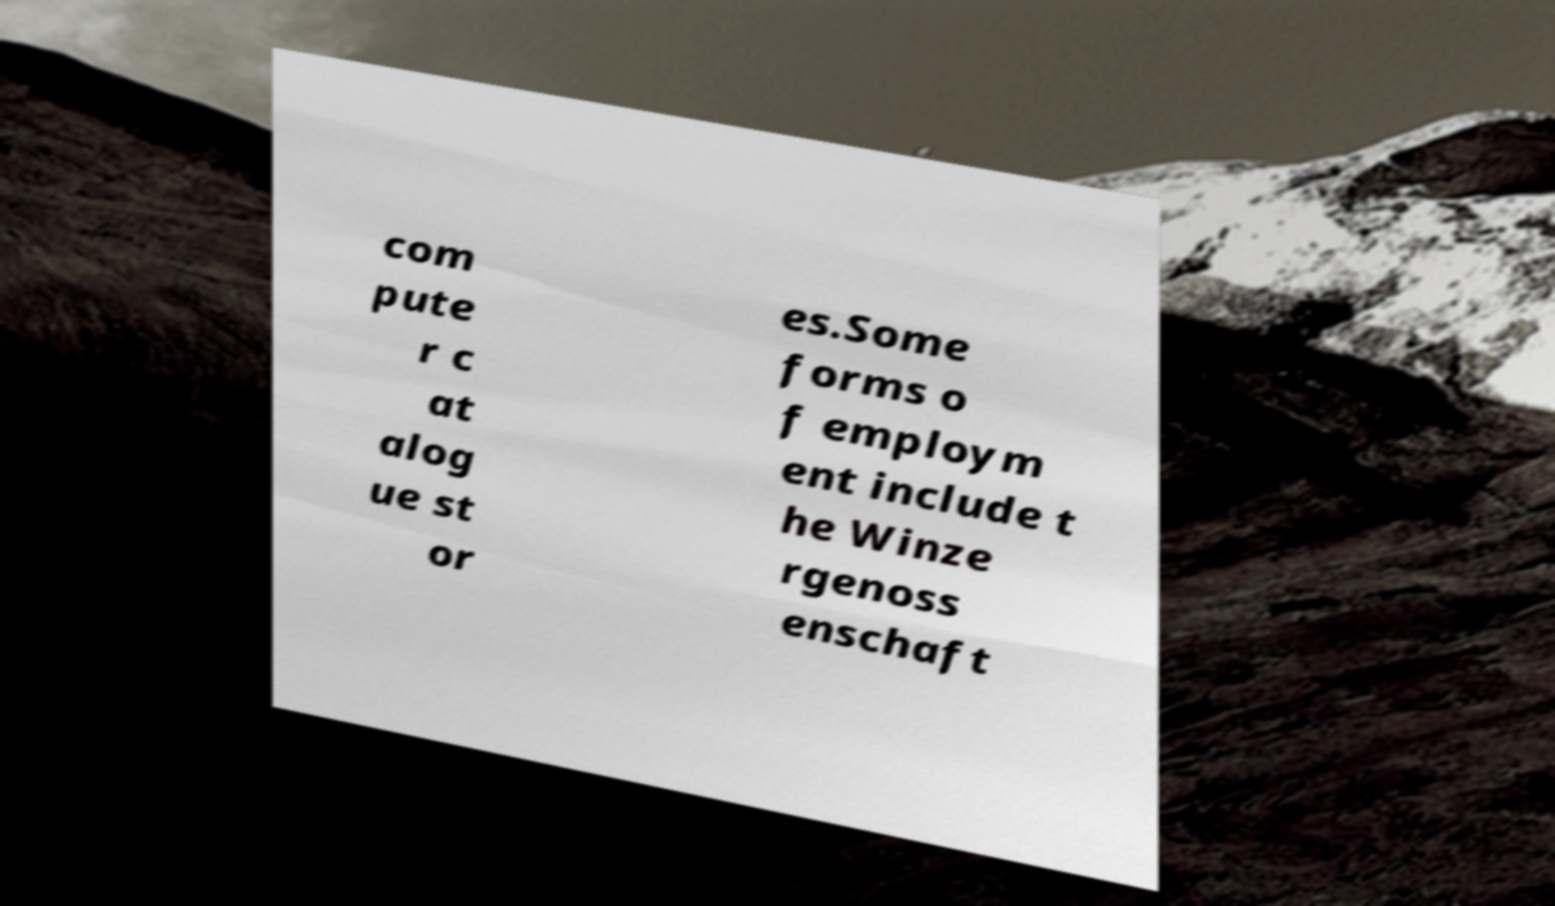Could you extract and type out the text from this image? com pute r c at alog ue st or es.Some forms o f employm ent include t he Winze rgenoss enschaft 